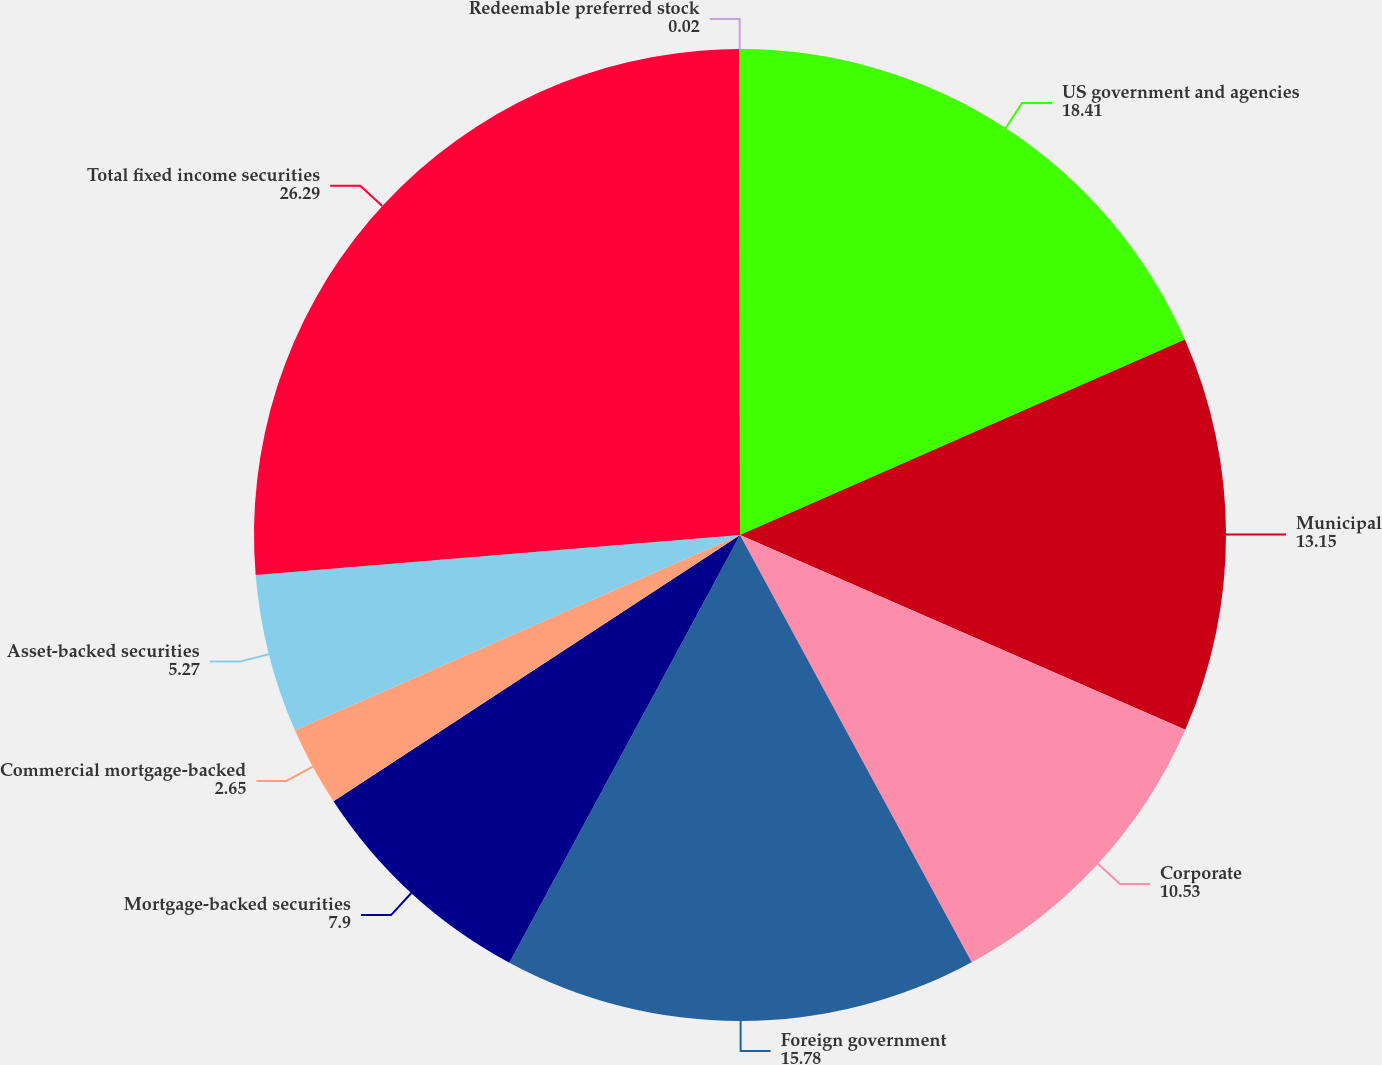<chart> <loc_0><loc_0><loc_500><loc_500><pie_chart><fcel>US government and agencies<fcel>Municipal<fcel>Corporate<fcel>Foreign government<fcel>Mortgage-backed securities<fcel>Commercial mortgage-backed<fcel>Asset-backed securities<fcel>Total fixed income securities<fcel>Redeemable preferred stock<nl><fcel>18.41%<fcel>13.15%<fcel>10.53%<fcel>15.78%<fcel>7.9%<fcel>2.65%<fcel>5.27%<fcel>26.29%<fcel>0.02%<nl></chart> 